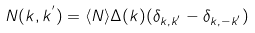Convert formula to latex. <formula><loc_0><loc_0><loc_500><loc_500>N ( { k } , { k } ^ { ^ { \prime } } ) = \langle N \rangle \Delta ( { k } ) ( \delta _ { { k } , { k } ^ { ^ { \prime } } } - \delta _ { { k } , - { k } ^ { ^ { \prime } } } )</formula> 